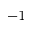Convert formula to latex. <formula><loc_0><loc_0><loc_500><loc_500>^ { - 1 }</formula> 